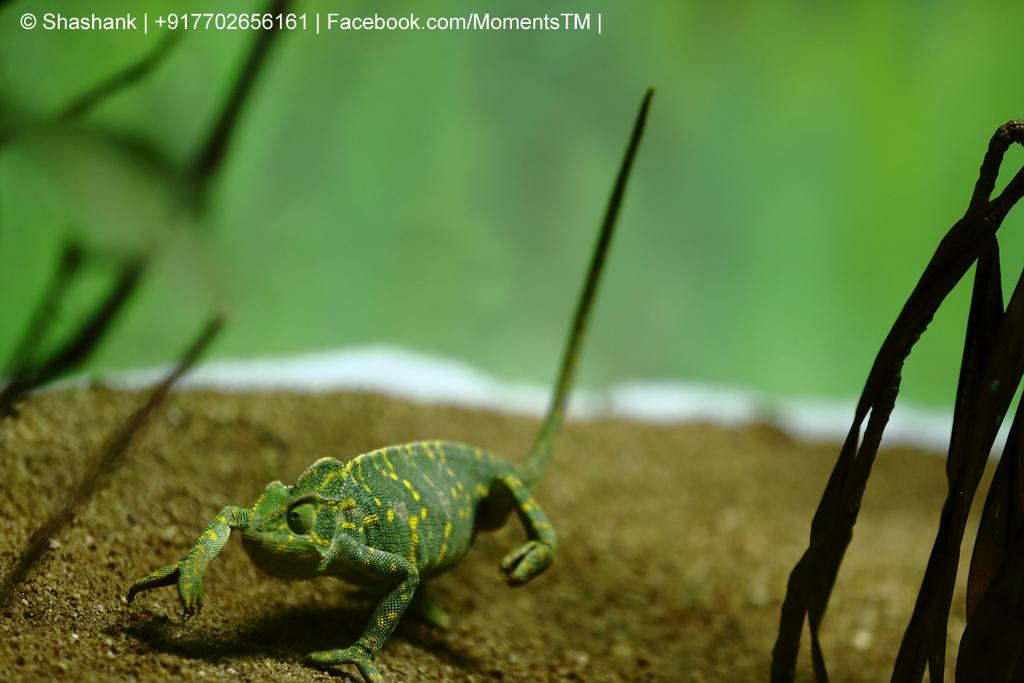What type of animal is in the image? There is a reptile in the image. What color is the reptile? The reptile is green in color. What can be found in the top left corner of the image? There is text in the top left corner of the image. What is the color of the background in the image? The background of the image is green. Can you see a knife being used by the reptile in the image? There is no knife present in the image, nor is the reptile using one. 